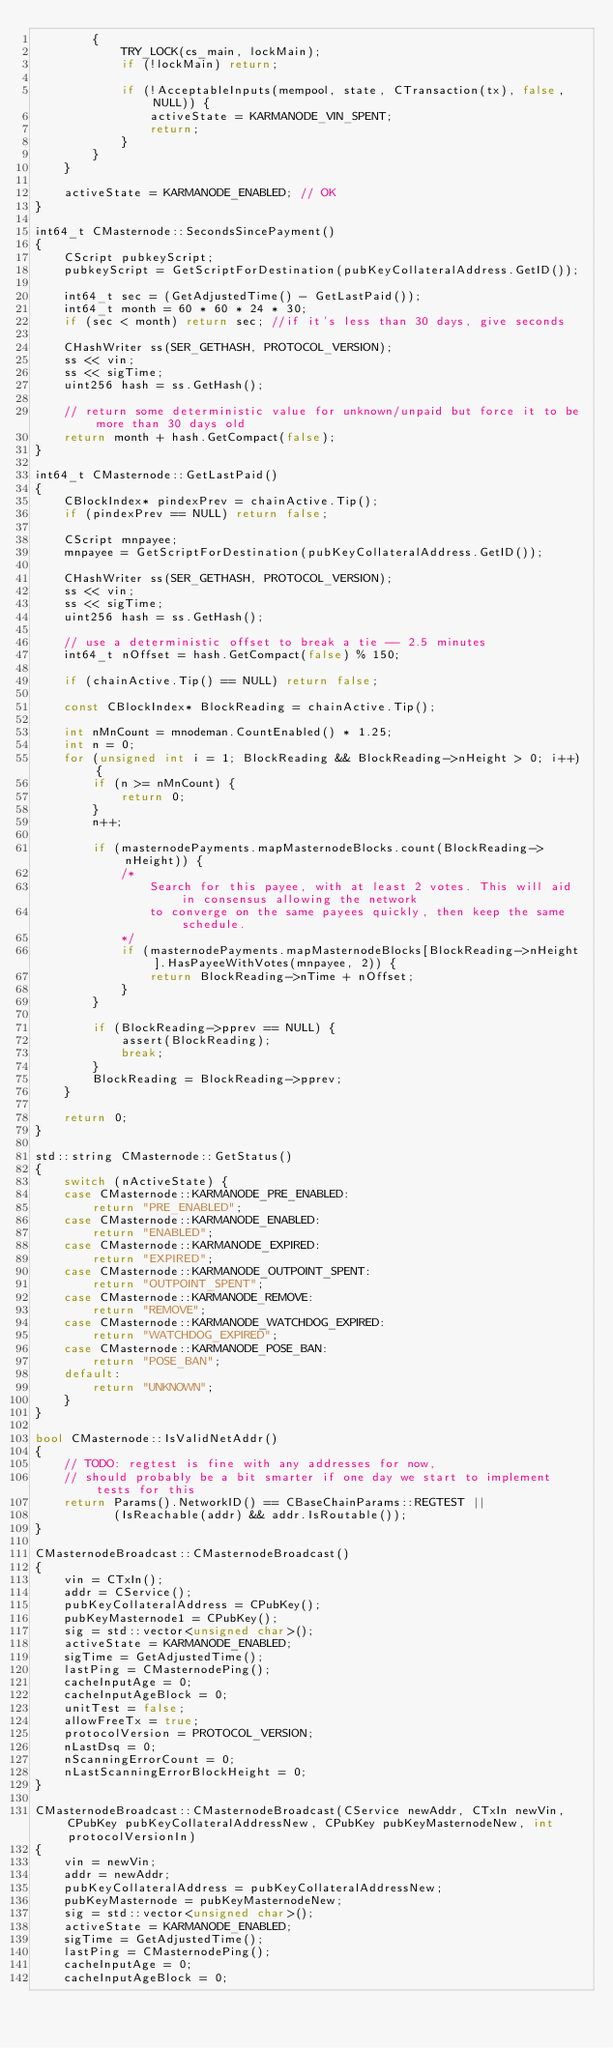Convert code to text. <code><loc_0><loc_0><loc_500><loc_500><_C++_>        {
            TRY_LOCK(cs_main, lockMain);
            if (!lockMain) return;

            if (!AcceptableInputs(mempool, state, CTransaction(tx), false, NULL)) {
                activeState = KARMANODE_VIN_SPENT;
                return;
            }
        }
    }

    activeState = KARMANODE_ENABLED; // OK
}

int64_t CMasternode::SecondsSincePayment()
{
    CScript pubkeyScript;
    pubkeyScript = GetScriptForDestination(pubKeyCollateralAddress.GetID());

    int64_t sec = (GetAdjustedTime() - GetLastPaid());
    int64_t month = 60 * 60 * 24 * 30;
    if (sec < month) return sec; //if it's less than 30 days, give seconds

    CHashWriter ss(SER_GETHASH, PROTOCOL_VERSION);
    ss << vin;
    ss << sigTime;
    uint256 hash = ss.GetHash();

    // return some deterministic value for unknown/unpaid but force it to be more than 30 days old
    return month + hash.GetCompact(false);
}

int64_t CMasternode::GetLastPaid()
{
    CBlockIndex* pindexPrev = chainActive.Tip();
    if (pindexPrev == NULL) return false;

    CScript mnpayee;
    mnpayee = GetScriptForDestination(pubKeyCollateralAddress.GetID());

    CHashWriter ss(SER_GETHASH, PROTOCOL_VERSION);
    ss << vin;
    ss << sigTime;
    uint256 hash = ss.GetHash();

    // use a deterministic offset to break a tie -- 2.5 minutes
    int64_t nOffset = hash.GetCompact(false) % 150;

    if (chainActive.Tip() == NULL) return false;

    const CBlockIndex* BlockReading = chainActive.Tip();

    int nMnCount = mnodeman.CountEnabled() * 1.25;
    int n = 0;
    for (unsigned int i = 1; BlockReading && BlockReading->nHeight > 0; i++) {
        if (n >= nMnCount) {
            return 0;
        }
        n++;

        if (masternodePayments.mapMasternodeBlocks.count(BlockReading->nHeight)) {
            /*
                Search for this payee, with at least 2 votes. This will aid in consensus allowing the network 
                to converge on the same payees quickly, then keep the same schedule.
            */
            if (masternodePayments.mapMasternodeBlocks[BlockReading->nHeight].HasPayeeWithVotes(mnpayee, 2)) {
                return BlockReading->nTime + nOffset;
            }
        }

        if (BlockReading->pprev == NULL) {
            assert(BlockReading);
            break;
        }
        BlockReading = BlockReading->pprev;
    }

    return 0;
}

std::string CMasternode::GetStatus()
{
    switch (nActiveState) {
    case CMasternode::KARMANODE_PRE_ENABLED:
        return "PRE_ENABLED";
    case CMasternode::KARMANODE_ENABLED:
        return "ENABLED";
    case CMasternode::KARMANODE_EXPIRED:
        return "EXPIRED";
    case CMasternode::KARMANODE_OUTPOINT_SPENT:
        return "OUTPOINT_SPENT";
    case CMasternode::KARMANODE_REMOVE:
        return "REMOVE";
    case CMasternode::KARMANODE_WATCHDOG_EXPIRED:
        return "WATCHDOG_EXPIRED";
    case CMasternode::KARMANODE_POSE_BAN:
        return "POSE_BAN";
    default:
        return "UNKNOWN";
    }
}

bool CMasternode::IsValidNetAddr()
{
    // TODO: regtest is fine with any addresses for now,
    // should probably be a bit smarter if one day we start to implement tests for this
    return Params().NetworkID() == CBaseChainParams::REGTEST ||
           (IsReachable(addr) && addr.IsRoutable());
}

CMasternodeBroadcast::CMasternodeBroadcast()
{
    vin = CTxIn();
    addr = CService();
    pubKeyCollateralAddress = CPubKey();
    pubKeyMasternode1 = CPubKey();
    sig = std::vector<unsigned char>();
    activeState = KARMANODE_ENABLED;
    sigTime = GetAdjustedTime();
    lastPing = CMasternodePing();
    cacheInputAge = 0;
    cacheInputAgeBlock = 0;
    unitTest = false;
    allowFreeTx = true;
    protocolVersion = PROTOCOL_VERSION;
    nLastDsq = 0;
    nScanningErrorCount = 0;
    nLastScanningErrorBlockHeight = 0;
}

CMasternodeBroadcast::CMasternodeBroadcast(CService newAddr, CTxIn newVin, CPubKey pubKeyCollateralAddressNew, CPubKey pubKeyMasternodeNew, int protocolVersionIn)
{
    vin = newVin;
    addr = newAddr;
    pubKeyCollateralAddress = pubKeyCollateralAddressNew;
    pubKeyMasternode = pubKeyMasternodeNew;
    sig = std::vector<unsigned char>();
    activeState = KARMANODE_ENABLED;
    sigTime = GetAdjustedTime();
    lastPing = CMasternodePing();
    cacheInputAge = 0;
    cacheInputAgeBlock = 0;</code> 